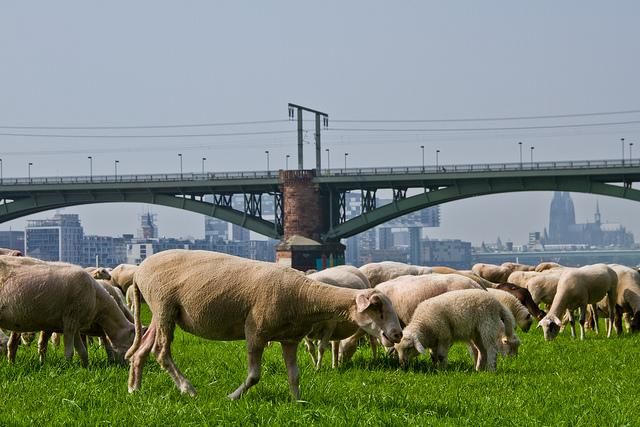What color is the cast iron component in the bridge above the grassy field?

Choices:
A) red
B) green
C) rust
D) blue green 